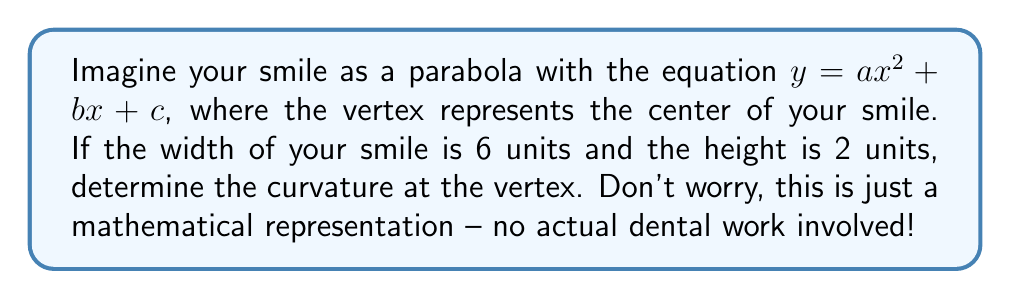Teach me how to tackle this problem. Let's approach this step-by-step, keeping in mind that we're just working with a friendly mathematical curve:

1) First, we need to find the equation of the parabola. Given that the width is 6 units and the height is 2 units, we can determine:

   - The vertex form of a parabola is $y = a(x-h)^2 + k$, where $(h,k)$ is the vertex.
   - The vertex is at the center, so $h = 0$.
   - The parabola passes through points $(-3,0)$, $(0,2)$, and $(3,0)$.

2) Using the point $(3,0)$, we can write:
   
   $0 = a(3)^2 + 2$
   $-2 = 9a$
   $a = -\frac{2}{9}$

3) So our parabola equation is:

   $y = -\frac{2}{9}x^2 + 2$

4) The curvature $\kappa$ of a curve $y=f(x)$ at a point is given by:

   $\kappa = \frac{|f''(x)|}{(1 + (f'(x))^2)^{3/2}}$

5) For our parabola:
   
   $f'(x) = -\frac{4}{9}x$
   $f''(x) = -\frac{4}{9}$

6) At the vertex $(0,2)$, $x=0$, so:

   $\kappa = \frac{|-\frac{4}{9}|}{(1 + (0)^2)^{3/2}} = \frac{4}{9}$

Remember, this is just a mathematical representation. No actual dental procedures are involved in calculating this curvature!
Answer: $\frac{4}{9}$ 